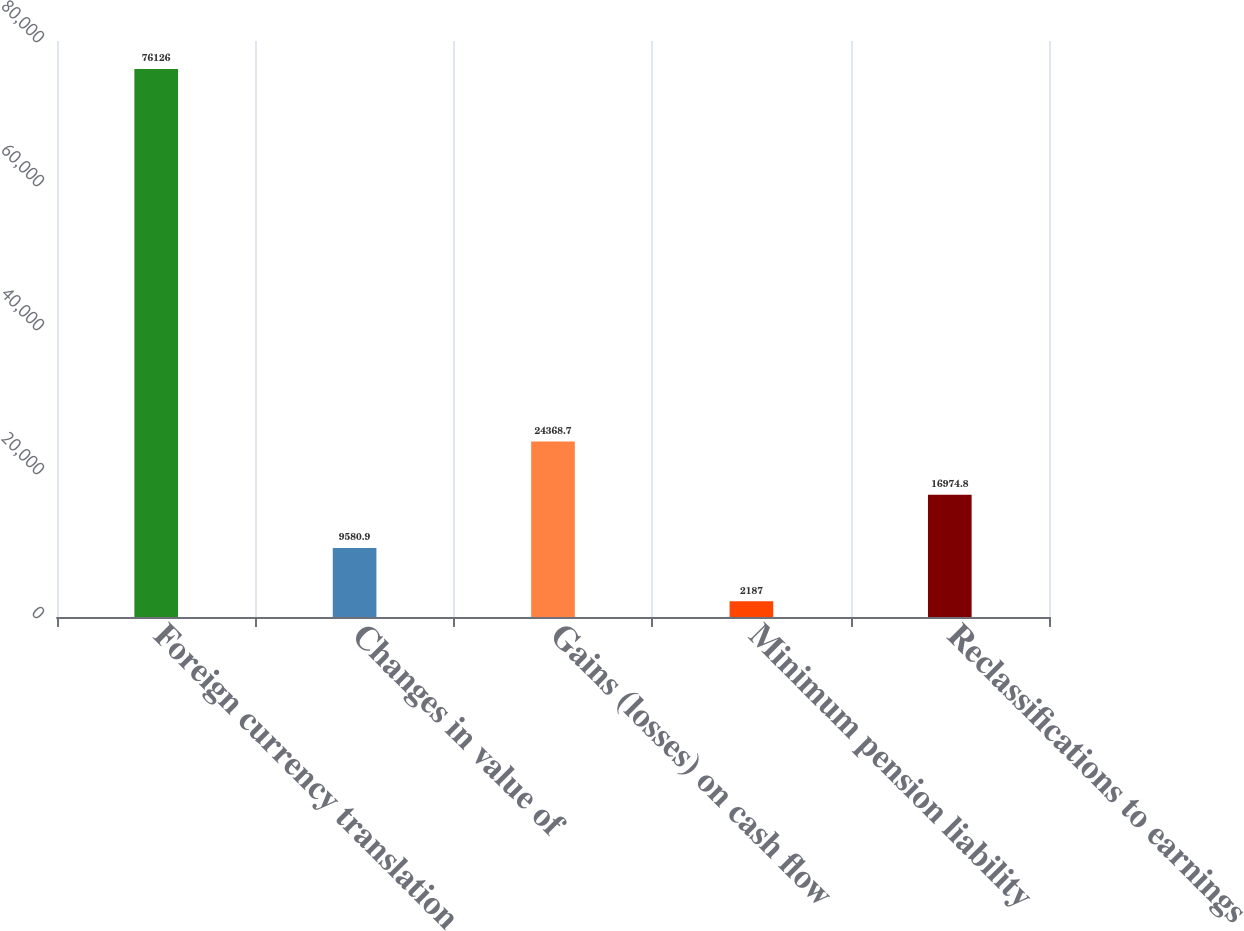Convert chart to OTSL. <chart><loc_0><loc_0><loc_500><loc_500><bar_chart><fcel>Foreign currency translation<fcel>Changes in value of<fcel>Gains (losses) on cash flow<fcel>Minimum pension liability<fcel>Reclassifications to earnings<nl><fcel>76126<fcel>9580.9<fcel>24368.7<fcel>2187<fcel>16974.8<nl></chart> 